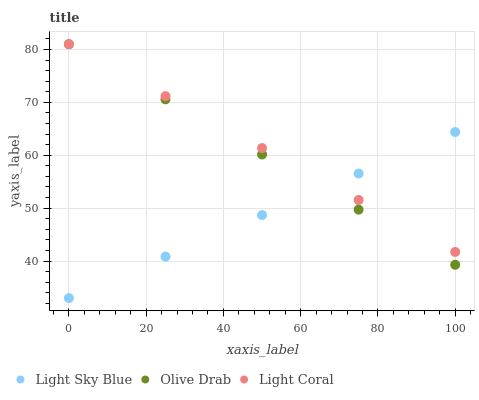Does Light Sky Blue have the minimum area under the curve?
Answer yes or no. Yes. Does Light Coral have the maximum area under the curve?
Answer yes or no. Yes. Does Olive Drab have the minimum area under the curve?
Answer yes or no. No. Does Olive Drab have the maximum area under the curve?
Answer yes or no. No. Is Olive Drab the smoothest?
Answer yes or no. Yes. Is Light Sky Blue the roughest?
Answer yes or no. Yes. Is Light Sky Blue the smoothest?
Answer yes or no. No. Is Olive Drab the roughest?
Answer yes or no. No. Does Light Sky Blue have the lowest value?
Answer yes or no. Yes. Does Olive Drab have the lowest value?
Answer yes or no. No. Does Olive Drab have the highest value?
Answer yes or no. Yes. Does Light Sky Blue have the highest value?
Answer yes or no. No. Does Light Sky Blue intersect Olive Drab?
Answer yes or no. Yes. Is Light Sky Blue less than Olive Drab?
Answer yes or no. No. Is Light Sky Blue greater than Olive Drab?
Answer yes or no. No. 